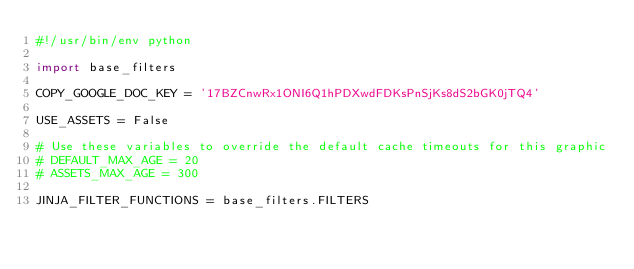Convert code to text. <code><loc_0><loc_0><loc_500><loc_500><_Python_>#!/usr/bin/env python

import base_filters

COPY_GOOGLE_DOC_KEY = '17BZCnwRx1ONI6Q1hPDXwdFDKsPnSjKs8dS2bGK0jTQ4'

USE_ASSETS = False

# Use these variables to override the default cache timeouts for this graphic
# DEFAULT_MAX_AGE = 20
# ASSETS_MAX_AGE = 300

JINJA_FILTER_FUNCTIONS = base_filters.FILTERS
</code> 